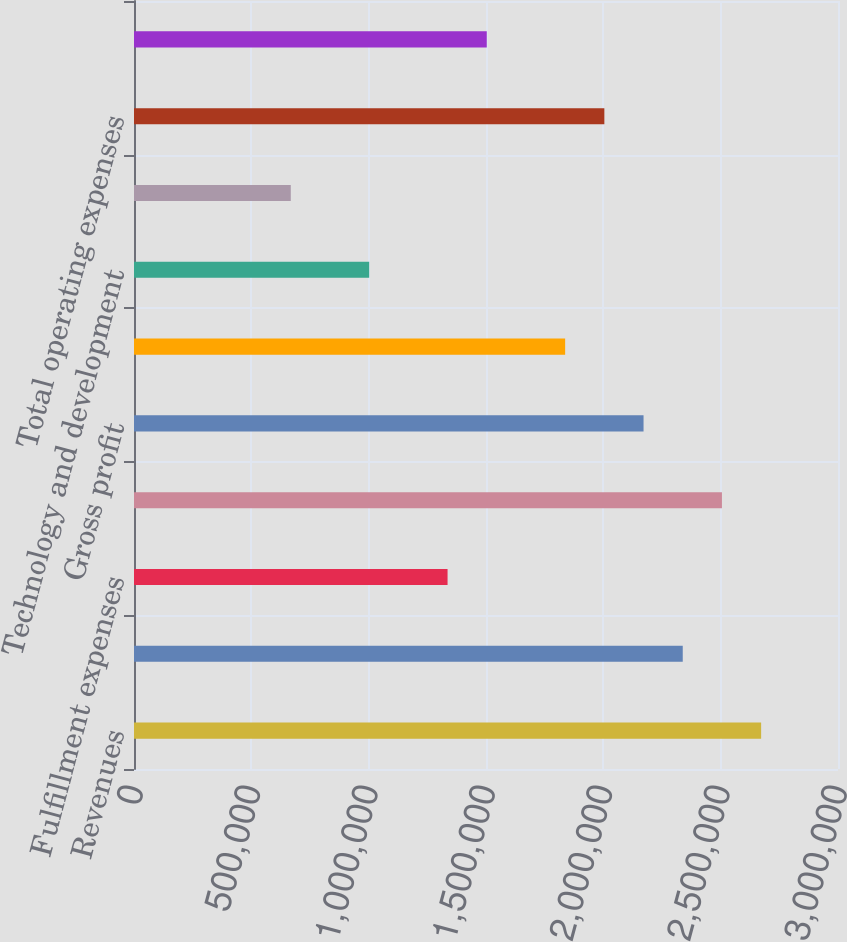Convert chart to OTSL. <chart><loc_0><loc_0><loc_500><loc_500><bar_chart><fcel>Revenues<fcel>Subscription<fcel>Fulfillment expenses<fcel>Total cost of revenues<fcel>Gross profit<fcel>Marketing<fcel>Technology and development<fcel>General and administrative<fcel>Total operating expenses<fcel>Operating income<nl><fcel>2.67243e+06<fcel>2.33838e+06<fcel>1.33622e+06<fcel>2.5054e+06<fcel>2.17135e+06<fcel>1.8373e+06<fcel>1.00216e+06<fcel>668109<fcel>2.00432e+06<fcel>1.50324e+06<nl></chart> 